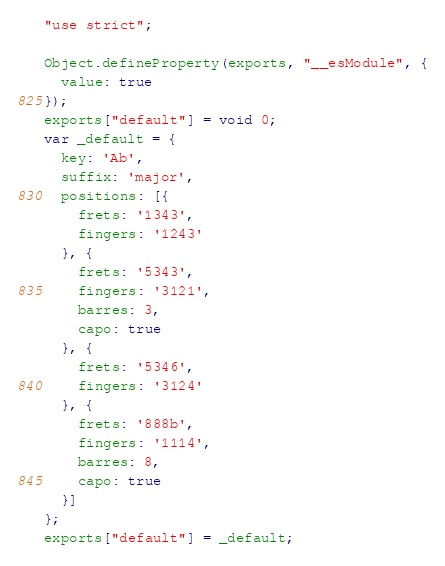<code> <loc_0><loc_0><loc_500><loc_500><_JavaScript_>"use strict";

Object.defineProperty(exports, "__esModule", {
  value: true
});
exports["default"] = void 0;
var _default = {
  key: 'Ab',
  suffix: 'major',
  positions: [{
    frets: '1343',
    fingers: '1243'
  }, {
    frets: '5343',
    fingers: '3121',
    barres: 3,
    capo: true
  }, {
    frets: '5346',
    fingers: '3124'
  }, {
    frets: '888b',
    fingers: '1114',
    barres: 8,
    capo: true
  }]
};
exports["default"] = _default;</code> 